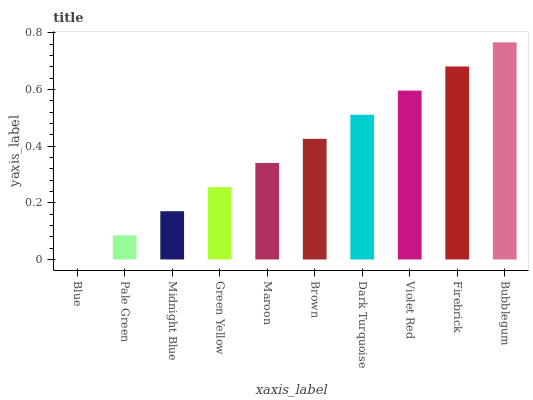Is Blue the minimum?
Answer yes or no. Yes. Is Bubblegum the maximum?
Answer yes or no. Yes. Is Pale Green the minimum?
Answer yes or no. No. Is Pale Green the maximum?
Answer yes or no. No. Is Pale Green greater than Blue?
Answer yes or no. Yes. Is Blue less than Pale Green?
Answer yes or no. Yes. Is Blue greater than Pale Green?
Answer yes or no. No. Is Pale Green less than Blue?
Answer yes or no. No. Is Brown the high median?
Answer yes or no. Yes. Is Maroon the low median?
Answer yes or no. Yes. Is Violet Red the high median?
Answer yes or no. No. Is Midnight Blue the low median?
Answer yes or no. No. 